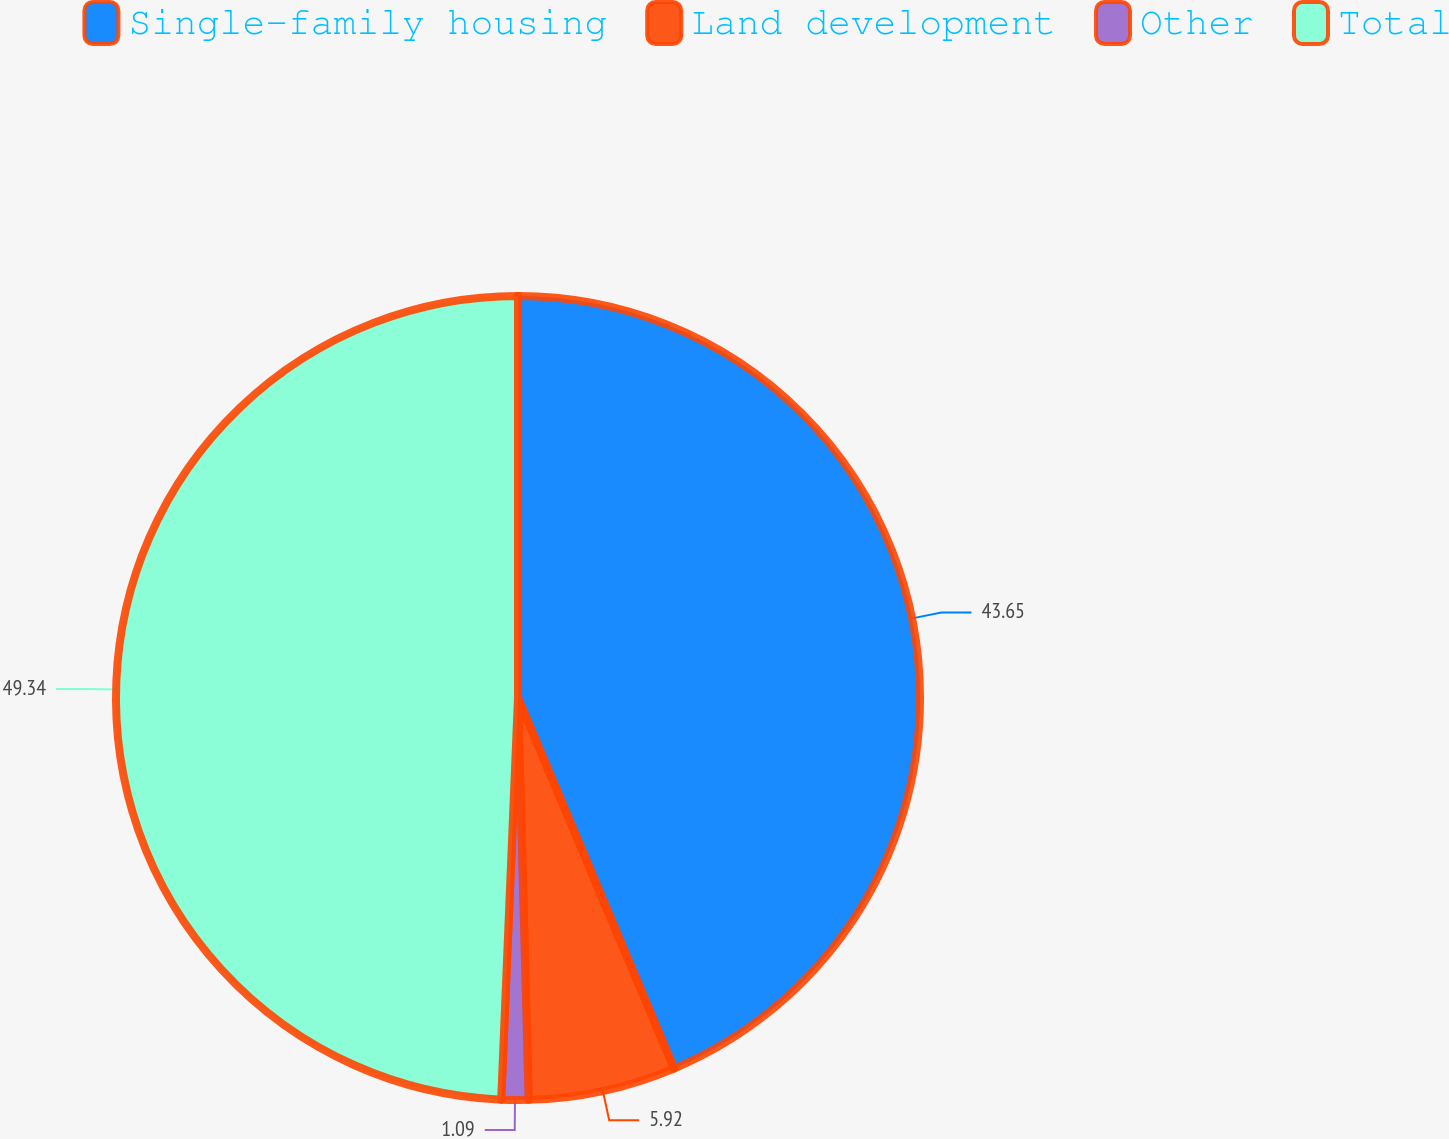<chart> <loc_0><loc_0><loc_500><loc_500><pie_chart><fcel>Single-family housing<fcel>Land development<fcel>Other<fcel>Total<nl><fcel>43.65%<fcel>5.92%<fcel>1.09%<fcel>49.33%<nl></chart> 